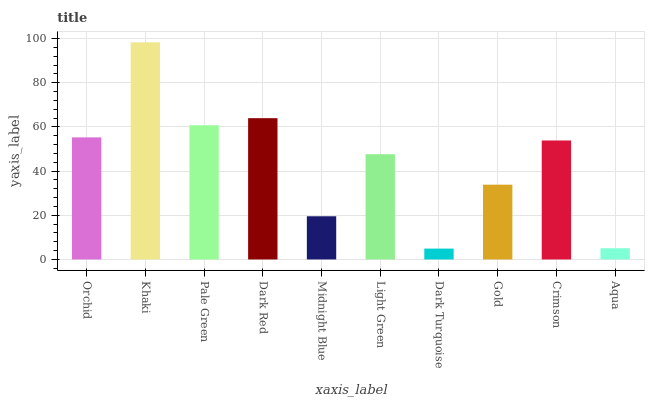Is Dark Turquoise the minimum?
Answer yes or no. Yes. Is Khaki the maximum?
Answer yes or no. Yes. Is Pale Green the minimum?
Answer yes or no. No. Is Pale Green the maximum?
Answer yes or no. No. Is Khaki greater than Pale Green?
Answer yes or no. Yes. Is Pale Green less than Khaki?
Answer yes or no. Yes. Is Pale Green greater than Khaki?
Answer yes or no. No. Is Khaki less than Pale Green?
Answer yes or no. No. Is Crimson the high median?
Answer yes or no. Yes. Is Light Green the low median?
Answer yes or no. Yes. Is Midnight Blue the high median?
Answer yes or no. No. Is Gold the low median?
Answer yes or no. No. 